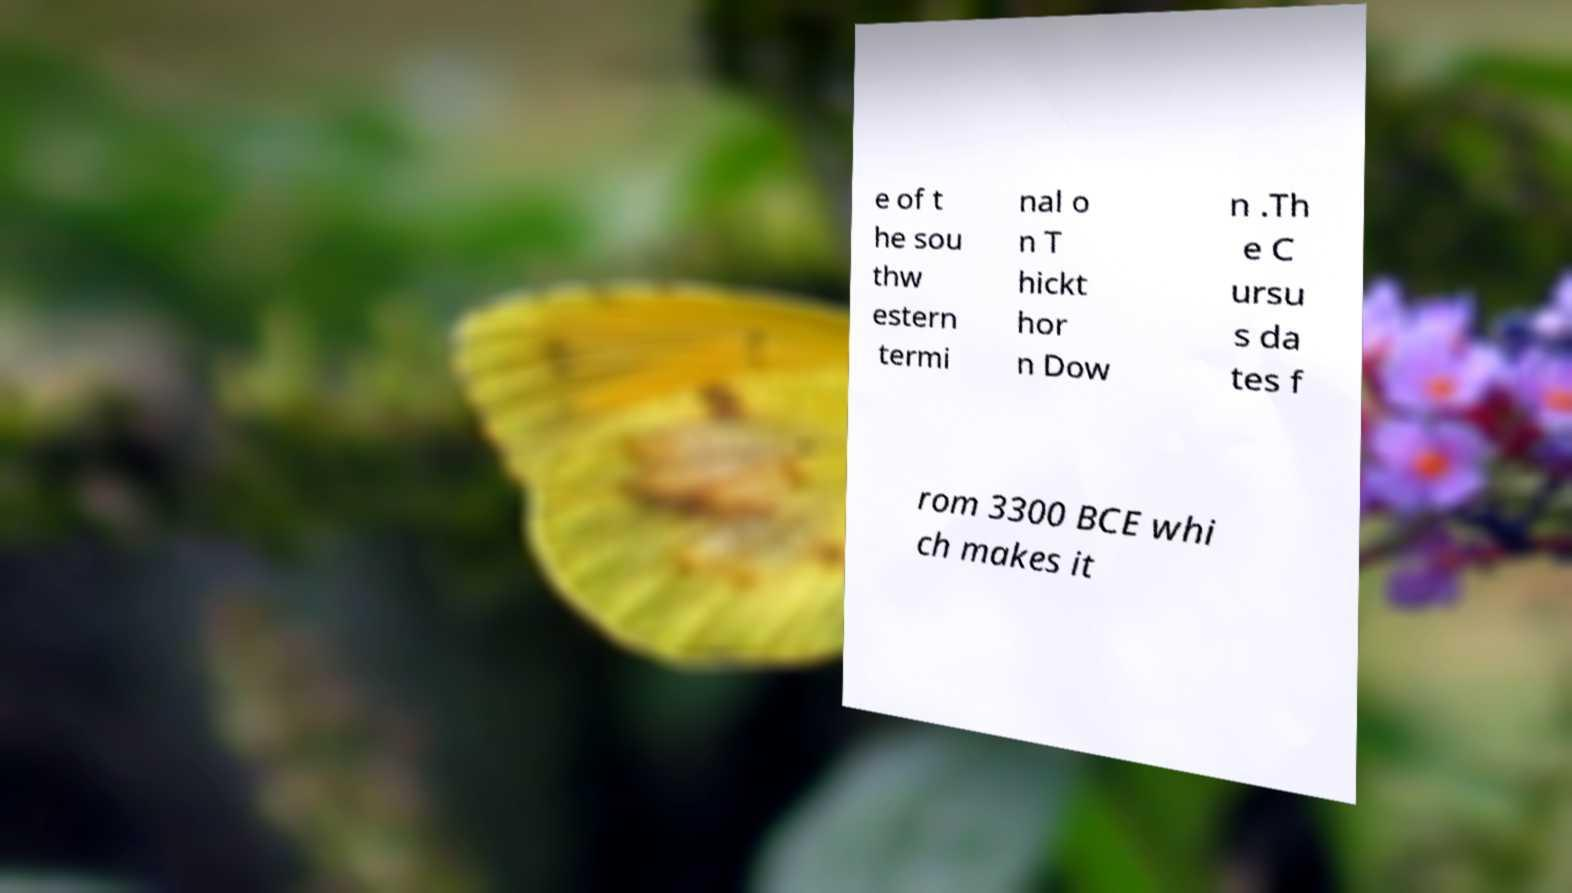I need the written content from this picture converted into text. Can you do that? e of t he sou thw estern termi nal o n T hickt hor n Dow n .Th e C ursu s da tes f rom 3300 BCE whi ch makes it 